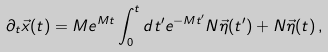Convert formula to latex. <formula><loc_0><loc_0><loc_500><loc_500>\partial _ { t } \vec { x } ( t ) = M e ^ { M t } \int _ { 0 } ^ { t } d t ^ { \prime } e ^ { - M t ^ { \prime } } N \vec { \eta } ( t ^ { \prime } ) + N \vec { \eta } ( t ) \, ,</formula> 